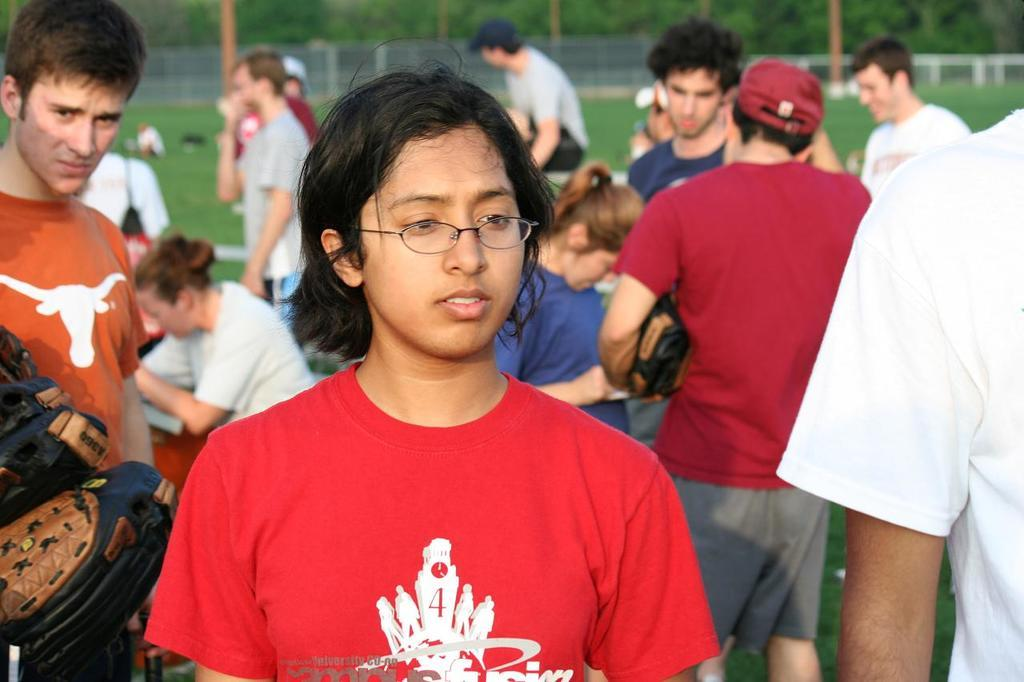What are the people in the image doing? The people in the image are standing on the grass. What can be seen at the back side of the image? There is a metal fence at the back side of the image. What is visible in the background of the image? There are trees visible in the background of the image. What degree does the person in the image hold? There is no indication of a person holding a degree in the image. 